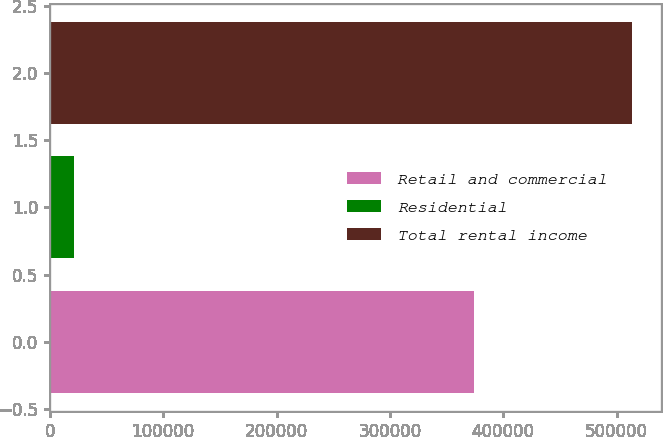Convert chart to OTSL. <chart><loc_0><loc_0><loc_500><loc_500><bar_chart><fcel>Retail and commercial<fcel>Residential<fcel>Total rental income<nl><fcel>373920<fcel>21093<fcel>513220<nl></chart> 